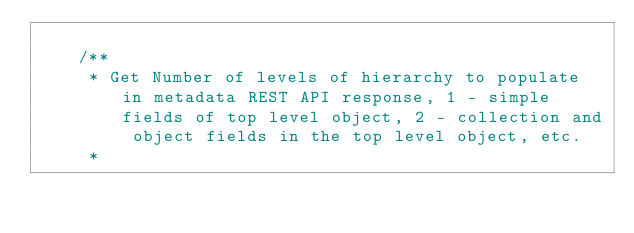Convert code to text. <code><loc_0><loc_0><loc_500><loc_500><_Java_>
    /**
     * Get Number of levels of hierarchy to populate in metadata REST API response, 1 - simple fields of top level object, 2 - collection and object fields in the top level object, etc.
     *</code> 